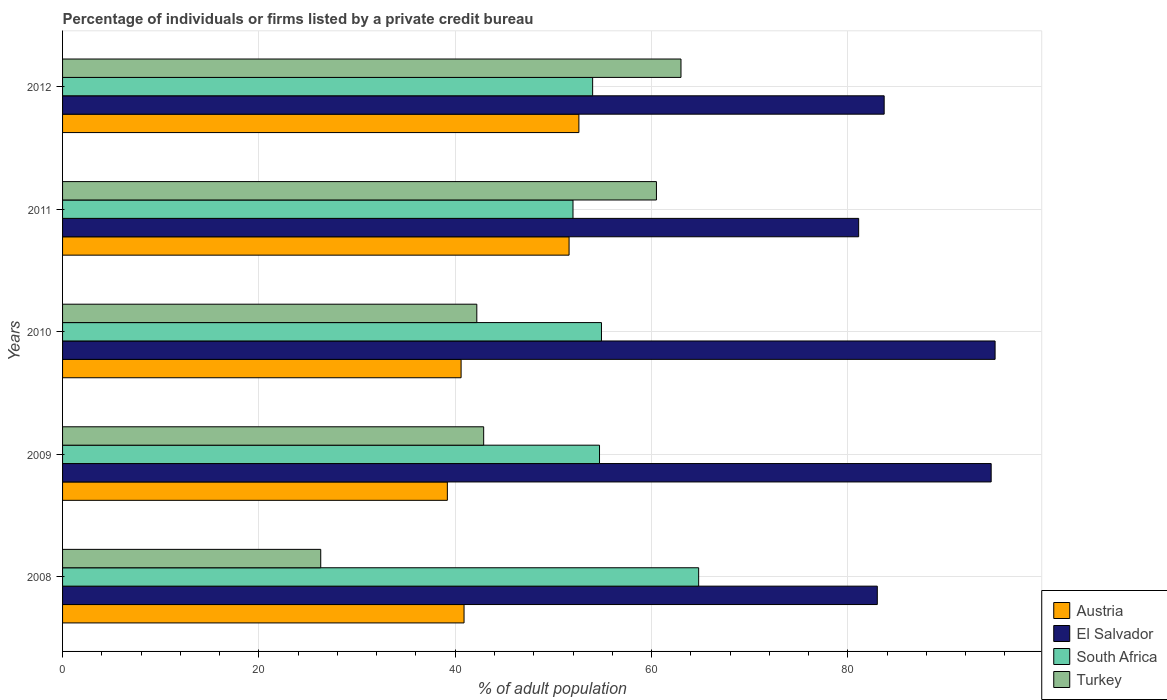How many different coloured bars are there?
Offer a terse response. 4. How many groups of bars are there?
Provide a succinct answer. 5. How many bars are there on the 3rd tick from the bottom?
Your response must be concise. 4. What is the label of the 3rd group of bars from the top?
Your response must be concise. 2010. In how many cases, is the number of bars for a given year not equal to the number of legend labels?
Your response must be concise. 0. What is the percentage of population listed by a private credit bureau in El Salvador in 2012?
Give a very brief answer. 83.7. Across all years, what is the maximum percentage of population listed by a private credit bureau in South Africa?
Make the answer very short. 64.8. Across all years, what is the minimum percentage of population listed by a private credit bureau in Turkey?
Offer a terse response. 26.3. In which year was the percentage of population listed by a private credit bureau in Austria maximum?
Your answer should be compact. 2012. In which year was the percentage of population listed by a private credit bureau in Turkey minimum?
Give a very brief answer. 2008. What is the total percentage of population listed by a private credit bureau in South Africa in the graph?
Your response must be concise. 280.4. What is the difference between the percentage of population listed by a private credit bureau in El Salvador in 2010 and that in 2011?
Provide a succinct answer. 13.9. What is the difference between the percentage of population listed by a private credit bureau in El Salvador in 2010 and the percentage of population listed by a private credit bureau in South Africa in 2009?
Your answer should be compact. 40.3. What is the average percentage of population listed by a private credit bureau in Austria per year?
Offer a terse response. 44.98. In the year 2009, what is the difference between the percentage of population listed by a private credit bureau in South Africa and percentage of population listed by a private credit bureau in Turkey?
Your response must be concise. 11.8. What is the ratio of the percentage of population listed by a private credit bureau in Turkey in 2008 to that in 2012?
Your answer should be compact. 0.42. Is the percentage of population listed by a private credit bureau in Austria in 2009 less than that in 2010?
Make the answer very short. Yes. What is the difference between the highest and the second highest percentage of population listed by a private credit bureau in El Salvador?
Ensure brevity in your answer.  0.4. What is the difference between the highest and the lowest percentage of population listed by a private credit bureau in El Salvador?
Give a very brief answer. 13.9. In how many years, is the percentage of population listed by a private credit bureau in Turkey greater than the average percentage of population listed by a private credit bureau in Turkey taken over all years?
Your answer should be compact. 2. Is the sum of the percentage of population listed by a private credit bureau in El Salvador in 2008 and 2012 greater than the maximum percentage of population listed by a private credit bureau in Austria across all years?
Ensure brevity in your answer.  Yes. Is it the case that in every year, the sum of the percentage of population listed by a private credit bureau in Turkey and percentage of population listed by a private credit bureau in El Salvador is greater than the sum of percentage of population listed by a private credit bureau in South Africa and percentage of population listed by a private credit bureau in Austria?
Your response must be concise. Yes. What does the 2nd bar from the top in 2010 represents?
Your response must be concise. South Africa. What does the 3rd bar from the bottom in 2008 represents?
Give a very brief answer. South Africa. Is it the case that in every year, the sum of the percentage of population listed by a private credit bureau in South Africa and percentage of population listed by a private credit bureau in Austria is greater than the percentage of population listed by a private credit bureau in Turkey?
Offer a very short reply. Yes. Does the graph contain any zero values?
Offer a very short reply. No. How are the legend labels stacked?
Your answer should be compact. Vertical. What is the title of the graph?
Your answer should be compact. Percentage of individuals or firms listed by a private credit bureau. Does "Israel" appear as one of the legend labels in the graph?
Your response must be concise. No. What is the label or title of the X-axis?
Your response must be concise. % of adult population. What is the % of adult population in Austria in 2008?
Your answer should be compact. 40.9. What is the % of adult population of South Africa in 2008?
Keep it short and to the point. 64.8. What is the % of adult population of Turkey in 2008?
Give a very brief answer. 26.3. What is the % of adult population in Austria in 2009?
Offer a terse response. 39.2. What is the % of adult population of El Salvador in 2009?
Make the answer very short. 94.6. What is the % of adult population in South Africa in 2009?
Offer a terse response. 54.7. What is the % of adult population in Turkey in 2009?
Your answer should be very brief. 42.9. What is the % of adult population in Austria in 2010?
Your response must be concise. 40.6. What is the % of adult population in South Africa in 2010?
Give a very brief answer. 54.9. What is the % of adult population in Turkey in 2010?
Your response must be concise. 42.2. What is the % of adult population in Austria in 2011?
Your answer should be compact. 51.6. What is the % of adult population in El Salvador in 2011?
Your answer should be compact. 81.1. What is the % of adult population of South Africa in 2011?
Keep it short and to the point. 52. What is the % of adult population in Turkey in 2011?
Ensure brevity in your answer.  60.5. What is the % of adult population of Austria in 2012?
Make the answer very short. 52.6. What is the % of adult population in El Salvador in 2012?
Provide a succinct answer. 83.7. Across all years, what is the maximum % of adult population of Austria?
Offer a terse response. 52.6. Across all years, what is the maximum % of adult population of South Africa?
Offer a very short reply. 64.8. Across all years, what is the minimum % of adult population of Austria?
Ensure brevity in your answer.  39.2. Across all years, what is the minimum % of adult population of El Salvador?
Provide a short and direct response. 81.1. Across all years, what is the minimum % of adult population in South Africa?
Your answer should be compact. 52. Across all years, what is the minimum % of adult population of Turkey?
Your answer should be compact. 26.3. What is the total % of adult population of Austria in the graph?
Provide a succinct answer. 224.9. What is the total % of adult population of El Salvador in the graph?
Offer a terse response. 437.4. What is the total % of adult population of South Africa in the graph?
Offer a very short reply. 280.4. What is the total % of adult population of Turkey in the graph?
Your response must be concise. 234.9. What is the difference between the % of adult population in El Salvador in 2008 and that in 2009?
Your answer should be compact. -11.6. What is the difference between the % of adult population of South Africa in 2008 and that in 2009?
Provide a short and direct response. 10.1. What is the difference between the % of adult population of Turkey in 2008 and that in 2009?
Ensure brevity in your answer.  -16.6. What is the difference between the % of adult population of Austria in 2008 and that in 2010?
Offer a very short reply. 0.3. What is the difference between the % of adult population in Turkey in 2008 and that in 2010?
Keep it short and to the point. -15.9. What is the difference between the % of adult population in El Salvador in 2008 and that in 2011?
Ensure brevity in your answer.  1.9. What is the difference between the % of adult population of South Africa in 2008 and that in 2011?
Offer a terse response. 12.8. What is the difference between the % of adult population of Turkey in 2008 and that in 2011?
Give a very brief answer. -34.2. What is the difference between the % of adult population of El Salvador in 2008 and that in 2012?
Offer a terse response. -0.7. What is the difference between the % of adult population of Turkey in 2008 and that in 2012?
Your answer should be compact. -36.7. What is the difference between the % of adult population in Austria in 2009 and that in 2010?
Make the answer very short. -1.4. What is the difference between the % of adult population of Austria in 2009 and that in 2011?
Make the answer very short. -12.4. What is the difference between the % of adult population in South Africa in 2009 and that in 2011?
Your answer should be very brief. 2.7. What is the difference between the % of adult population in Turkey in 2009 and that in 2011?
Your response must be concise. -17.6. What is the difference between the % of adult population in Turkey in 2009 and that in 2012?
Your answer should be compact. -20.1. What is the difference between the % of adult population of El Salvador in 2010 and that in 2011?
Keep it short and to the point. 13.9. What is the difference between the % of adult population in South Africa in 2010 and that in 2011?
Give a very brief answer. 2.9. What is the difference between the % of adult population of Turkey in 2010 and that in 2011?
Provide a succinct answer. -18.3. What is the difference between the % of adult population of Austria in 2010 and that in 2012?
Your answer should be compact. -12. What is the difference between the % of adult population of Turkey in 2010 and that in 2012?
Provide a short and direct response. -20.8. What is the difference between the % of adult population in El Salvador in 2011 and that in 2012?
Provide a succinct answer. -2.6. What is the difference between the % of adult population in Austria in 2008 and the % of adult population in El Salvador in 2009?
Provide a succinct answer. -53.7. What is the difference between the % of adult population of Austria in 2008 and the % of adult population of South Africa in 2009?
Provide a short and direct response. -13.8. What is the difference between the % of adult population of Austria in 2008 and the % of adult population of Turkey in 2009?
Give a very brief answer. -2. What is the difference between the % of adult population in El Salvador in 2008 and the % of adult population in South Africa in 2009?
Keep it short and to the point. 28.3. What is the difference between the % of adult population in El Salvador in 2008 and the % of adult population in Turkey in 2009?
Your answer should be compact. 40.1. What is the difference between the % of adult population in South Africa in 2008 and the % of adult population in Turkey in 2009?
Offer a very short reply. 21.9. What is the difference between the % of adult population of Austria in 2008 and the % of adult population of El Salvador in 2010?
Provide a succinct answer. -54.1. What is the difference between the % of adult population in Austria in 2008 and the % of adult population in South Africa in 2010?
Give a very brief answer. -14. What is the difference between the % of adult population in El Salvador in 2008 and the % of adult population in South Africa in 2010?
Make the answer very short. 28.1. What is the difference between the % of adult population in El Salvador in 2008 and the % of adult population in Turkey in 2010?
Your answer should be very brief. 40.8. What is the difference between the % of adult population of South Africa in 2008 and the % of adult population of Turkey in 2010?
Your answer should be very brief. 22.6. What is the difference between the % of adult population in Austria in 2008 and the % of adult population in El Salvador in 2011?
Your response must be concise. -40.2. What is the difference between the % of adult population of Austria in 2008 and the % of adult population of South Africa in 2011?
Your answer should be compact. -11.1. What is the difference between the % of adult population of Austria in 2008 and the % of adult population of Turkey in 2011?
Offer a terse response. -19.6. What is the difference between the % of adult population of Austria in 2008 and the % of adult population of El Salvador in 2012?
Your response must be concise. -42.8. What is the difference between the % of adult population in Austria in 2008 and the % of adult population in South Africa in 2012?
Keep it short and to the point. -13.1. What is the difference between the % of adult population of Austria in 2008 and the % of adult population of Turkey in 2012?
Give a very brief answer. -22.1. What is the difference between the % of adult population of Austria in 2009 and the % of adult population of El Salvador in 2010?
Your response must be concise. -55.8. What is the difference between the % of adult population of Austria in 2009 and the % of adult population of South Africa in 2010?
Give a very brief answer. -15.7. What is the difference between the % of adult population in El Salvador in 2009 and the % of adult population in South Africa in 2010?
Offer a very short reply. 39.7. What is the difference between the % of adult population in El Salvador in 2009 and the % of adult population in Turkey in 2010?
Offer a terse response. 52.4. What is the difference between the % of adult population in South Africa in 2009 and the % of adult population in Turkey in 2010?
Offer a terse response. 12.5. What is the difference between the % of adult population of Austria in 2009 and the % of adult population of El Salvador in 2011?
Your response must be concise. -41.9. What is the difference between the % of adult population of Austria in 2009 and the % of adult population of South Africa in 2011?
Make the answer very short. -12.8. What is the difference between the % of adult population of Austria in 2009 and the % of adult population of Turkey in 2011?
Give a very brief answer. -21.3. What is the difference between the % of adult population in El Salvador in 2009 and the % of adult population in South Africa in 2011?
Keep it short and to the point. 42.6. What is the difference between the % of adult population of El Salvador in 2009 and the % of adult population of Turkey in 2011?
Make the answer very short. 34.1. What is the difference between the % of adult population of South Africa in 2009 and the % of adult population of Turkey in 2011?
Give a very brief answer. -5.8. What is the difference between the % of adult population in Austria in 2009 and the % of adult population in El Salvador in 2012?
Your answer should be compact. -44.5. What is the difference between the % of adult population of Austria in 2009 and the % of adult population of South Africa in 2012?
Your answer should be compact. -14.8. What is the difference between the % of adult population of Austria in 2009 and the % of adult population of Turkey in 2012?
Offer a very short reply. -23.8. What is the difference between the % of adult population in El Salvador in 2009 and the % of adult population in South Africa in 2012?
Provide a short and direct response. 40.6. What is the difference between the % of adult population in El Salvador in 2009 and the % of adult population in Turkey in 2012?
Offer a very short reply. 31.6. What is the difference between the % of adult population of South Africa in 2009 and the % of adult population of Turkey in 2012?
Your response must be concise. -8.3. What is the difference between the % of adult population of Austria in 2010 and the % of adult population of El Salvador in 2011?
Offer a terse response. -40.5. What is the difference between the % of adult population of Austria in 2010 and the % of adult population of Turkey in 2011?
Ensure brevity in your answer.  -19.9. What is the difference between the % of adult population of El Salvador in 2010 and the % of adult population of Turkey in 2011?
Keep it short and to the point. 34.5. What is the difference between the % of adult population in Austria in 2010 and the % of adult population in El Salvador in 2012?
Ensure brevity in your answer.  -43.1. What is the difference between the % of adult population in Austria in 2010 and the % of adult population in Turkey in 2012?
Provide a short and direct response. -22.4. What is the difference between the % of adult population of El Salvador in 2010 and the % of adult population of South Africa in 2012?
Offer a very short reply. 41. What is the difference between the % of adult population of Austria in 2011 and the % of adult population of El Salvador in 2012?
Ensure brevity in your answer.  -32.1. What is the difference between the % of adult population of Austria in 2011 and the % of adult population of South Africa in 2012?
Provide a short and direct response. -2.4. What is the difference between the % of adult population in Austria in 2011 and the % of adult population in Turkey in 2012?
Offer a terse response. -11.4. What is the difference between the % of adult population of El Salvador in 2011 and the % of adult population of South Africa in 2012?
Offer a terse response. 27.1. What is the difference between the % of adult population in South Africa in 2011 and the % of adult population in Turkey in 2012?
Provide a short and direct response. -11. What is the average % of adult population of Austria per year?
Your answer should be compact. 44.98. What is the average % of adult population of El Salvador per year?
Ensure brevity in your answer.  87.48. What is the average % of adult population of South Africa per year?
Your answer should be very brief. 56.08. What is the average % of adult population of Turkey per year?
Keep it short and to the point. 46.98. In the year 2008, what is the difference between the % of adult population of Austria and % of adult population of El Salvador?
Ensure brevity in your answer.  -42.1. In the year 2008, what is the difference between the % of adult population of Austria and % of adult population of South Africa?
Your answer should be very brief. -23.9. In the year 2008, what is the difference between the % of adult population of Austria and % of adult population of Turkey?
Provide a short and direct response. 14.6. In the year 2008, what is the difference between the % of adult population of El Salvador and % of adult population of Turkey?
Your response must be concise. 56.7. In the year 2008, what is the difference between the % of adult population in South Africa and % of adult population in Turkey?
Offer a terse response. 38.5. In the year 2009, what is the difference between the % of adult population in Austria and % of adult population in El Salvador?
Offer a very short reply. -55.4. In the year 2009, what is the difference between the % of adult population of Austria and % of adult population of South Africa?
Provide a short and direct response. -15.5. In the year 2009, what is the difference between the % of adult population in El Salvador and % of adult population in South Africa?
Make the answer very short. 39.9. In the year 2009, what is the difference between the % of adult population in El Salvador and % of adult population in Turkey?
Ensure brevity in your answer.  51.7. In the year 2009, what is the difference between the % of adult population in South Africa and % of adult population in Turkey?
Your response must be concise. 11.8. In the year 2010, what is the difference between the % of adult population of Austria and % of adult population of El Salvador?
Provide a short and direct response. -54.4. In the year 2010, what is the difference between the % of adult population in Austria and % of adult population in South Africa?
Ensure brevity in your answer.  -14.3. In the year 2010, what is the difference between the % of adult population of El Salvador and % of adult population of South Africa?
Your answer should be compact. 40.1. In the year 2010, what is the difference between the % of adult population in El Salvador and % of adult population in Turkey?
Make the answer very short. 52.8. In the year 2011, what is the difference between the % of adult population in Austria and % of adult population in El Salvador?
Provide a short and direct response. -29.5. In the year 2011, what is the difference between the % of adult population of Austria and % of adult population of South Africa?
Ensure brevity in your answer.  -0.4. In the year 2011, what is the difference between the % of adult population in El Salvador and % of adult population in South Africa?
Your response must be concise. 29.1. In the year 2011, what is the difference between the % of adult population of El Salvador and % of adult population of Turkey?
Keep it short and to the point. 20.6. In the year 2011, what is the difference between the % of adult population in South Africa and % of adult population in Turkey?
Your answer should be compact. -8.5. In the year 2012, what is the difference between the % of adult population in Austria and % of adult population in El Salvador?
Your response must be concise. -31.1. In the year 2012, what is the difference between the % of adult population of Austria and % of adult population of South Africa?
Provide a succinct answer. -1.4. In the year 2012, what is the difference between the % of adult population of Austria and % of adult population of Turkey?
Offer a terse response. -10.4. In the year 2012, what is the difference between the % of adult population of El Salvador and % of adult population of South Africa?
Your answer should be compact. 29.7. In the year 2012, what is the difference between the % of adult population in El Salvador and % of adult population in Turkey?
Keep it short and to the point. 20.7. In the year 2012, what is the difference between the % of adult population in South Africa and % of adult population in Turkey?
Provide a succinct answer. -9. What is the ratio of the % of adult population of Austria in 2008 to that in 2009?
Your answer should be very brief. 1.04. What is the ratio of the % of adult population of El Salvador in 2008 to that in 2009?
Your response must be concise. 0.88. What is the ratio of the % of adult population in South Africa in 2008 to that in 2009?
Your answer should be compact. 1.18. What is the ratio of the % of adult population of Turkey in 2008 to that in 2009?
Your answer should be compact. 0.61. What is the ratio of the % of adult population in Austria in 2008 to that in 2010?
Ensure brevity in your answer.  1.01. What is the ratio of the % of adult population in El Salvador in 2008 to that in 2010?
Offer a very short reply. 0.87. What is the ratio of the % of adult population of South Africa in 2008 to that in 2010?
Offer a terse response. 1.18. What is the ratio of the % of adult population of Turkey in 2008 to that in 2010?
Your answer should be very brief. 0.62. What is the ratio of the % of adult population of Austria in 2008 to that in 2011?
Your response must be concise. 0.79. What is the ratio of the % of adult population in El Salvador in 2008 to that in 2011?
Provide a short and direct response. 1.02. What is the ratio of the % of adult population of South Africa in 2008 to that in 2011?
Provide a short and direct response. 1.25. What is the ratio of the % of adult population in Turkey in 2008 to that in 2011?
Provide a succinct answer. 0.43. What is the ratio of the % of adult population of Austria in 2008 to that in 2012?
Provide a succinct answer. 0.78. What is the ratio of the % of adult population in El Salvador in 2008 to that in 2012?
Your answer should be very brief. 0.99. What is the ratio of the % of adult population in South Africa in 2008 to that in 2012?
Your answer should be compact. 1.2. What is the ratio of the % of adult population in Turkey in 2008 to that in 2012?
Ensure brevity in your answer.  0.42. What is the ratio of the % of adult population of Austria in 2009 to that in 2010?
Give a very brief answer. 0.97. What is the ratio of the % of adult population in El Salvador in 2009 to that in 2010?
Provide a short and direct response. 1. What is the ratio of the % of adult population of South Africa in 2009 to that in 2010?
Offer a very short reply. 1. What is the ratio of the % of adult population in Turkey in 2009 to that in 2010?
Provide a short and direct response. 1.02. What is the ratio of the % of adult population in Austria in 2009 to that in 2011?
Keep it short and to the point. 0.76. What is the ratio of the % of adult population of El Salvador in 2009 to that in 2011?
Your answer should be very brief. 1.17. What is the ratio of the % of adult population of South Africa in 2009 to that in 2011?
Offer a very short reply. 1.05. What is the ratio of the % of adult population in Turkey in 2009 to that in 2011?
Offer a terse response. 0.71. What is the ratio of the % of adult population in Austria in 2009 to that in 2012?
Provide a succinct answer. 0.75. What is the ratio of the % of adult population of El Salvador in 2009 to that in 2012?
Your answer should be compact. 1.13. What is the ratio of the % of adult population in South Africa in 2009 to that in 2012?
Offer a terse response. 1.01. What is the ratio of the % of adult population in Turkey in 2009 to that in 2012?
Offer a very short reply. 0.68. What is the ratio of the % of adult population in Austria in 2010 to that in 2011?
Provide a short and direct response. 0.79. What is the ratio of the % of adult population in El Salvador in 2010 to that in 2011?
Provide a short and direct response. 1.17. What is the ratio of the % of adult population in South Africa in 2010 to that in 2011?
Your response must be concise. 1.06. What is the ratio of the % of adult population in Turkey in 2010 to that in 2011?
Ensure brevity in your answer.  0.7. What is the ratio of the % of adult population of Austria in 2010 to that in 2012?
Give a very brief answer. 0.77. What is the ratio of the % of adult population of El Salvador in 2010 to that in 2012?
Make the answer very short. 1.14. What is the ratio of the % of adult population of South Africa in 2010 to that in 2012?
Offer a very short reply. 1.02. What is the ratio of the % of adult population of Turkey in 2010 to that in 2012?
Give a very brief answer. 0.67. What is the ratio of the % of adult population of El Salvador in 2011 to that in 2012?
Provide a short and direct response. 0.97. What is the ratio of the % of adult population in Turkey in 2011 to that in 2012?
Offer a terse response. 0.96. What is the difference between the highest and the second highest % of adult population of Turkey?
Provide a short and direct response. 2.5. What is the difference between the highest and the lowest % of adult population of Austria?
Your answer should be very brief. 13.4. What is the difference between the highest and the lowest % of adult population of El Salvador?
Offer a terse response. 13.9. What is the difference between the highest and the lowest % of adult population of Turkey?
Offer a terse response. 36.7. 